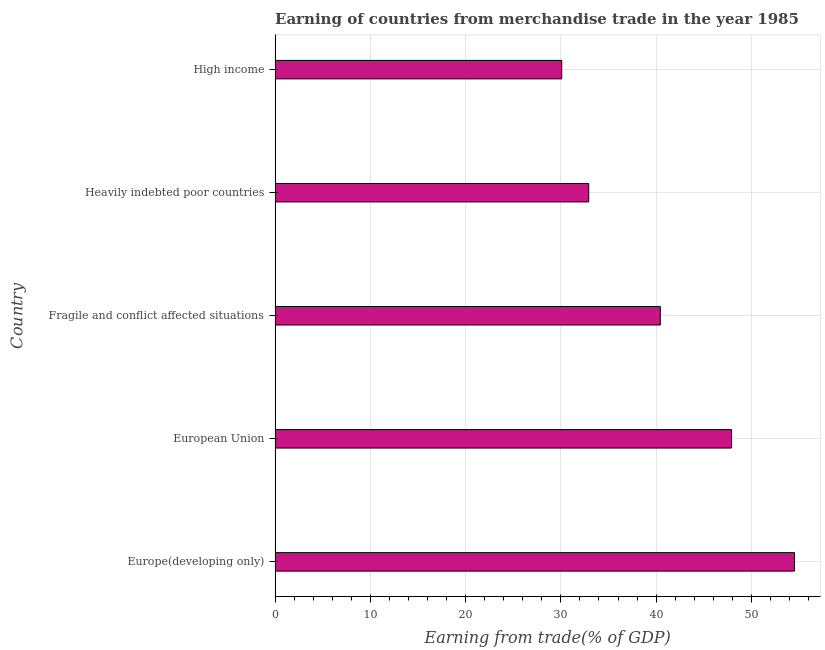Does the graph contain any zero values?
Your answer should be compact. No. What is the title of the graph?
Your answer should be very brief. Earning of countries from merchandise trade in the year 1985. What is the label or title of the X-axis?
Your answer should be compact. Earning from trade(% of GDP). What is the label or title of the Y-axis?
Your answer should be compact. Country. What is the earning from merchandise trade in High income?
Keep it short and to the point. 30.09. Across all countries, what is the maximum earning from merchandise trade?
Give a very brief answer. 54.53. Across all countries, what is the minimum earning from merchandise trade?
Give a very brief answer. 30.09. In which country was the earning from merchandise trade maximum?
Offer a terse response. Europe(developing only). What is the sum of the earning from merchandise trade?
Provide a succinct answer. 205.91. What is the difference between the earning from merchandise trade in Europe(developing only) and European Union?
Your answer should be compact. 6.61. What is the average earning from merchandise trade per country?
Keep it short and to the point. 41.18. What is the median earning from merchandise trade?
Your answer should be compact. 40.44. In how many countries, is the earning from merchandise trade greater than 28 %?
Keep it short and to the point. 5. What is the ratio of the earning from merchandise trade in Heavily indebted poor countries to that in High income?
Offer a very short reply. 1.09. What is the difference between the highest and the second highest earning from merchandise trade?
Ensure brevity in your answer.  6.61. What is the difference between the highest and the lowest earning from merchandise trade?
Ensure brevity in your answer.  24.44. In how many countries, is the earning from merchandise trade greater than the average earning from merchandise trade taken over all countries?
Offer a very short reply. 2. How many bars are there?
Keep it short and to the point. 5. Are all the bars in the graph horizontal?
Your response must be concise. Yes. How many countries are there in the graph?
Offer a very short reply. 5. What is the difference between two consecutive major ticks on the X-axis?
Your answer should be very brief. 10. What is the Earning from trade(% of GDP) in Europe(developing only)?
Provide a short and direct response. 54.53. What is the Earning from trade(% of GDP) in European Union?
Give a very brief answer. 47.92. What is the Earning from trade(% of GDP) of Fragile and conflict affected situations?
Your answer should be compact. 40.44. What is the Earning from trade(% of GDP) in Heavily indebted poor countries?
Make the answer very short. 32.93. What is the Earning from trade(% of GDP) of High income?
Provide a succinct answer. 30.09. What is the difference between the Earning from trade(% of GDP) in Europe(developing only) and European Union?
Provide a short and direct response. 6.61. What is the difference between the Earning from trade(% of GDP) in Europe(developing only) and Fragile and conflict affected situations?
Keep it short and to the point. 14.09. What is the difference between the Earning from trade(% of GDP) in Europe(developing only) and Heavily indebted poor countries?
Ensure brevity in your answer.  21.61. What is the difference between the Earning from trade(% of GDP) in Europe(developing only) and High income?
Ensure brevity in your answer.  24.44. What is the difference between the Earning from trade(% of GDP) in European Union and Fragile and conflict affected situations?
Give a very brief answer. 7.48. What is the difference between the Earning from trade(% of GDP) in European Union and Heavily indebted poor countries?
Your answer should be compact. 14.99. What is the difference between the Earning from trade(% of GDP) in European Union and High income?
Offer a terse response. 17.83. What is the difference between the Earning from trade(% of GDP) in Fragile and conflict affected situations and Heavily indebted poor countries?
Your answer should be very brief. 7.52. What is the difference between the Earning from trade(% of GDP) in Fragile and conflict affected situations and High income?
Provide a short and direct response. 10.35. What is the difference between the Earning from trade(% of GDP) in Heavily indebted poor countries and High income?
Give a very brief answer. 2.83. What is the ratio of the Earning from trade(% of GDP) in Europe(developing only) to that in European Union?
Ensure brevity in your answer.  1.14. What is the ratio of the Earning from trade(% of GDP) in Europe(developing only) to that in Fragile and conflict affected situations?
Offer a very short reply. 1.35. What is the ratio of the Earning from trade(% of GDP) in Europe(developing only) to that in Heavily indebted poor countries?
Give a very brief answer. 1.66. What is the ratio of the Earning from trade(% of GDP) in Europe(developing only) to that in High income?
Offer a terse response. 1.81. What is the ratio of the Earning from trade(% of GDP) in European Union to that in Fragile and conflict affected situations?
Make the answer very short. 1.19. What is the ratio of the Earning from trade(% of GDP) in European Union to that in Heavily indebted poor countries?
Give a very brief answer. 1.46. What is the ratio of the Earning from trade(% of GDP) in European Union to that in High income?
Offer a terse response. 1.59. What is the ratio of the Earning from trade(% of GDP) in Fragile and conflict affected situations to that in Heavily indebted poor countries?
Keep it short and to the point. 1.23. What is the ratio of the Earning from trade(% of GDP) in Fragile and conflict affected situations to that in High income?
Make the answer very short. 1.34. What is the ratio of the Earning from trade(% of GDP) in Heavily indebted poor countries to that in High income?
Offer a very short reply. 1.09. 